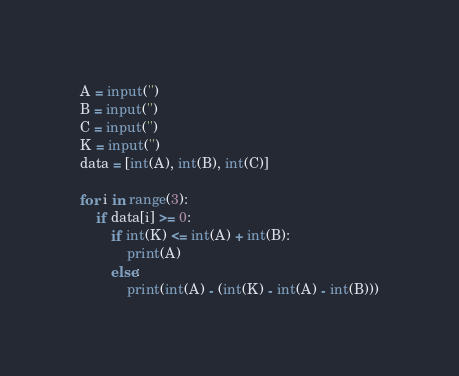<code> <loc_0><loc_0><loc_500><loc_500><_Python_>A = input('')
B = input('')
C = input('')
K = input('')
data = [int(A), int(B), int(C)]

for i in range(3):
    if data[i] >= 0:
        if int(K) <= int(A) + int(B):
            print(A)
        else:
            print(int(A) - (int(K) - int(A) - int(B)))</code> 